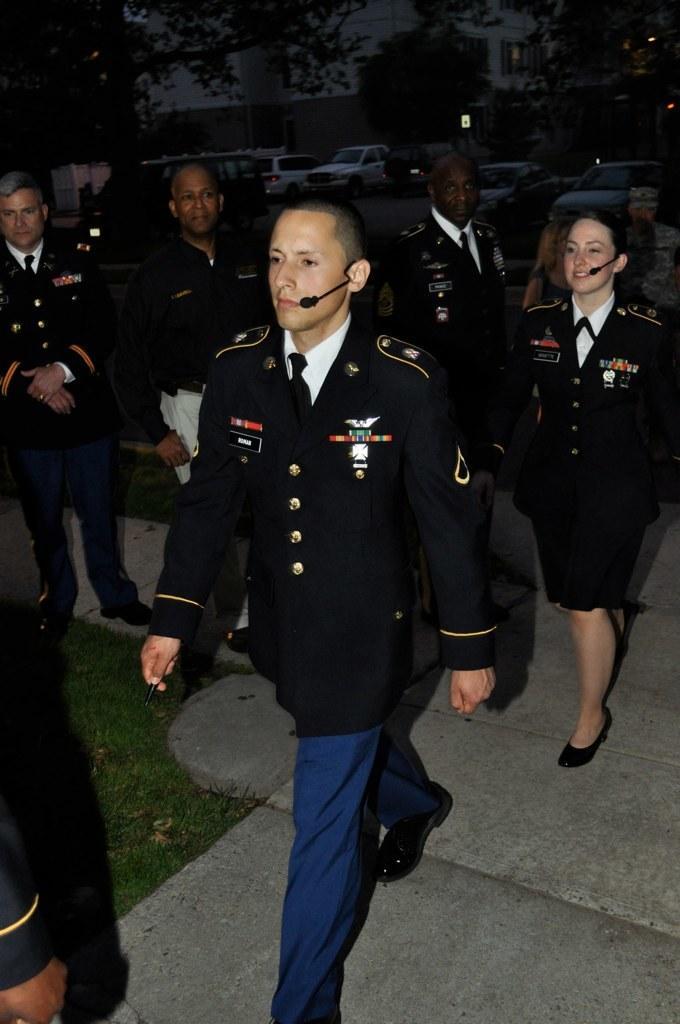In one or two sentences, can you explain what this image depicts? In this image there are a group of people who are wearing uniforms, and in the background there are some vehicles, trees, buildings and some lights. At the bottom there is walkway and grass. 